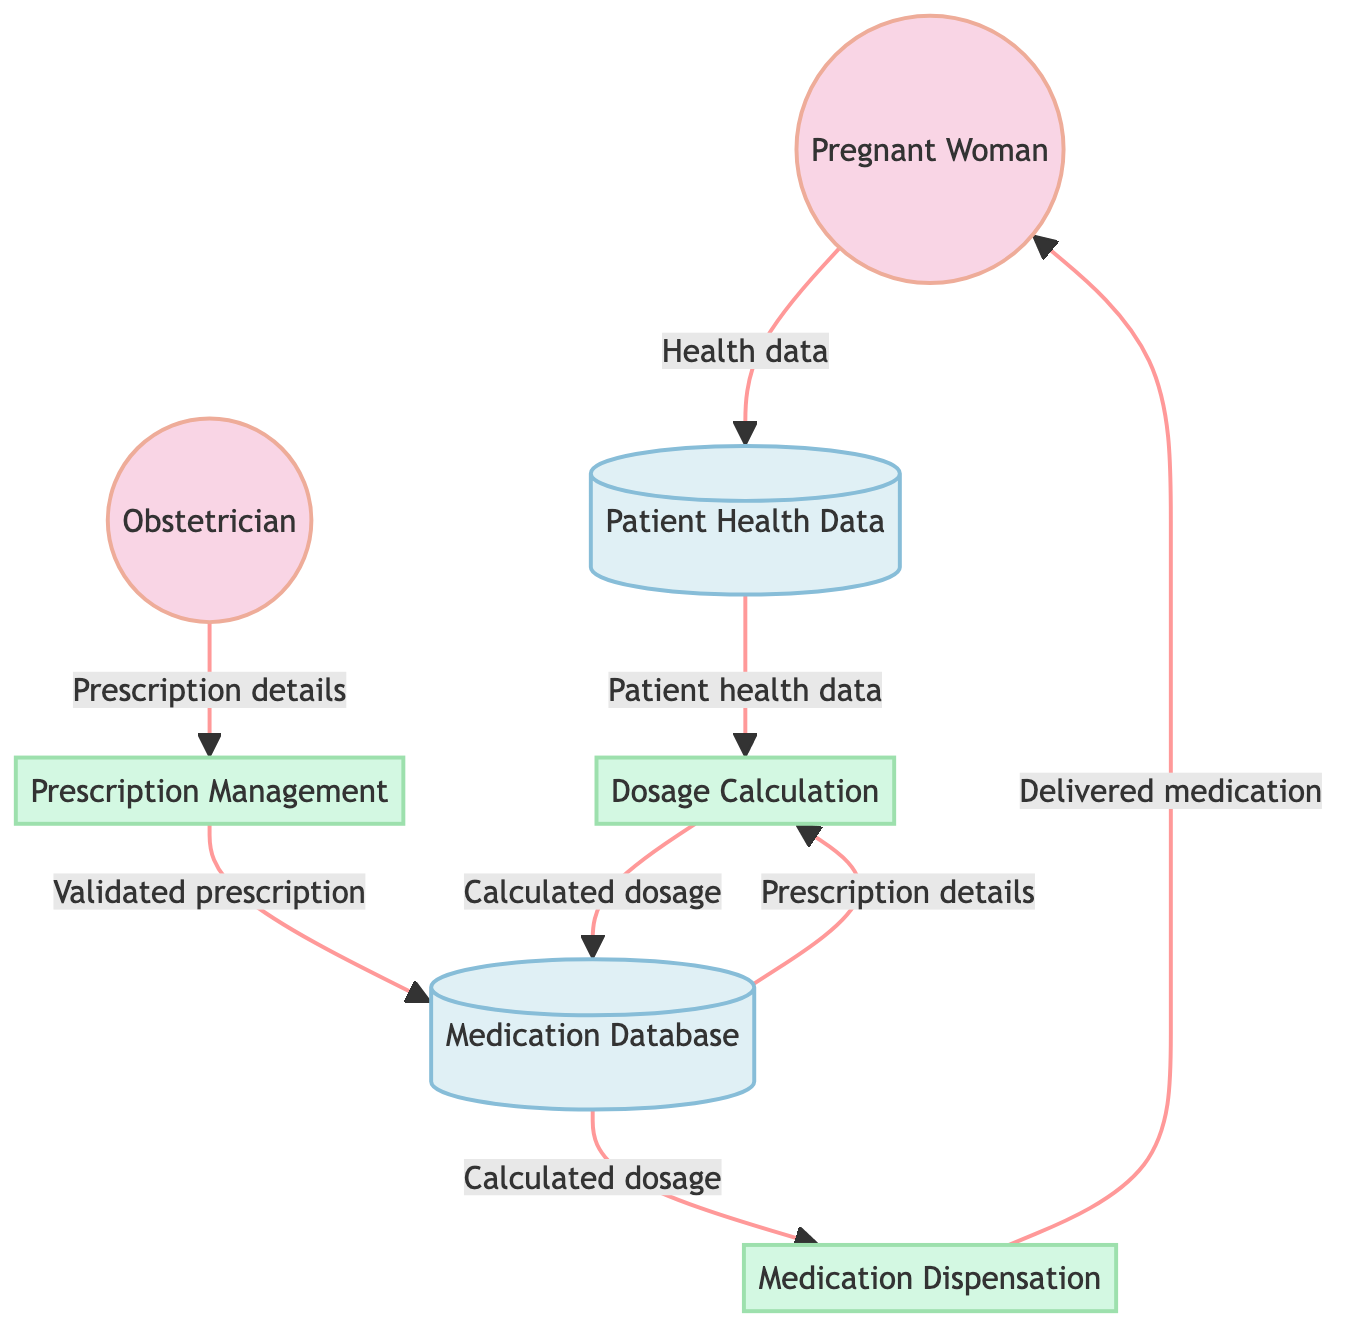What's the first external entity in the diagram? The first external entity represented in the diagram is "Pregnant Woman." It appears at the top left of the diagram, indicating the primary user of the system.
Answer: Pregnant Woman How many processes are represented in the diagram? There are three processes shown in the diagram: "Prescription Management," "Dosage Calculation," and "Medication Dispensation." Each process is clearly labeled and differentiated from data stores and external entities.
Answer: 3 What does the "Prescription Management" process output? The "Prescription Management" process outputs to the "Medication Database," indicating that the validated prescription details are stored there after processing.
Answer: Medication Database Which data store provides input to the "Dosage Calculation" process? Both "Medication Database" and "Patient Health Data" provide input to the "Dosage Calculation" process. The flow lines indicate that prescription details and patient health data are essential for calculating the dosage.
Answer: Medication Database and Patient Health Data What is delivered to the "Pregnant Woman" at the end of the process flow? The output of the "Medication Dispensation" process is "Delivered Medication," which indicates that the final action in the system is to deliver the prescribed medication to the pregnant woman.
Answer: Delivered Medication Which external entity initiates the medication process flow? The "Obstetrician" is the external entity that initiates the flow by providing the prescription details to the "Prescription Management" process. This establishes the starting point of medication management in the system.
Answer: Obstetrician What is the purpose of the "Patient Health Data" data store? The purpose of the "Patient Health Data" data store is to store health data specific to the pregnant woman, such as weight, blood pressure, and other relevant metrics that are necessary for dosage calculation.
Answer: Store health data Where does the "Calculated Dosage" output flow after "Dosage Calculation"? After the "Dosage Calculation," the "Calculated Dosage" flows into the "Medication Database," where the calculated dosage is stored for further use in dispensing medication.
Answer: Medication Database 